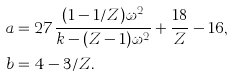Convert formula to latex. <formula><loc_0><loc_0><loc_500><loc_500>a & = 2 7 \frac { ( 1 - 1 / Z ) \omega ^ { 2 } } { k - ( Z - 1 ) \omega ^ { 2 } } + \frac { 1 8 } { Z } - 1 6 , \\ b & = 4 - 3 / Z .</formula> 